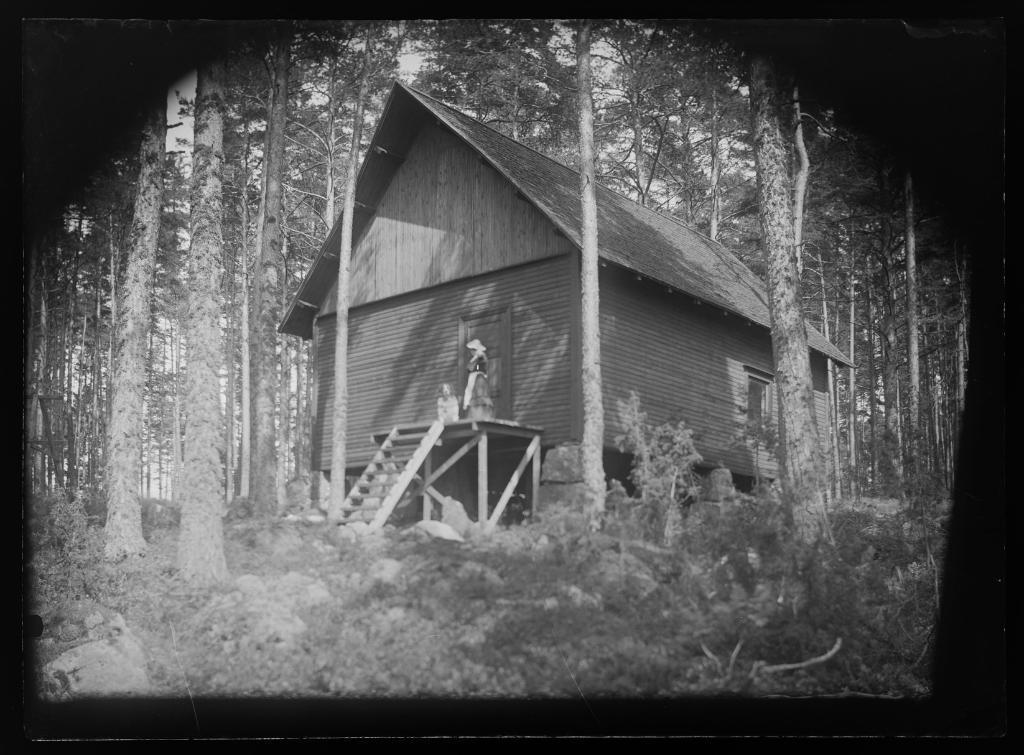Can you describe this image briefly? As we can see in the image there is a hut, ladder, two people over here, plants, rocks and trees. 